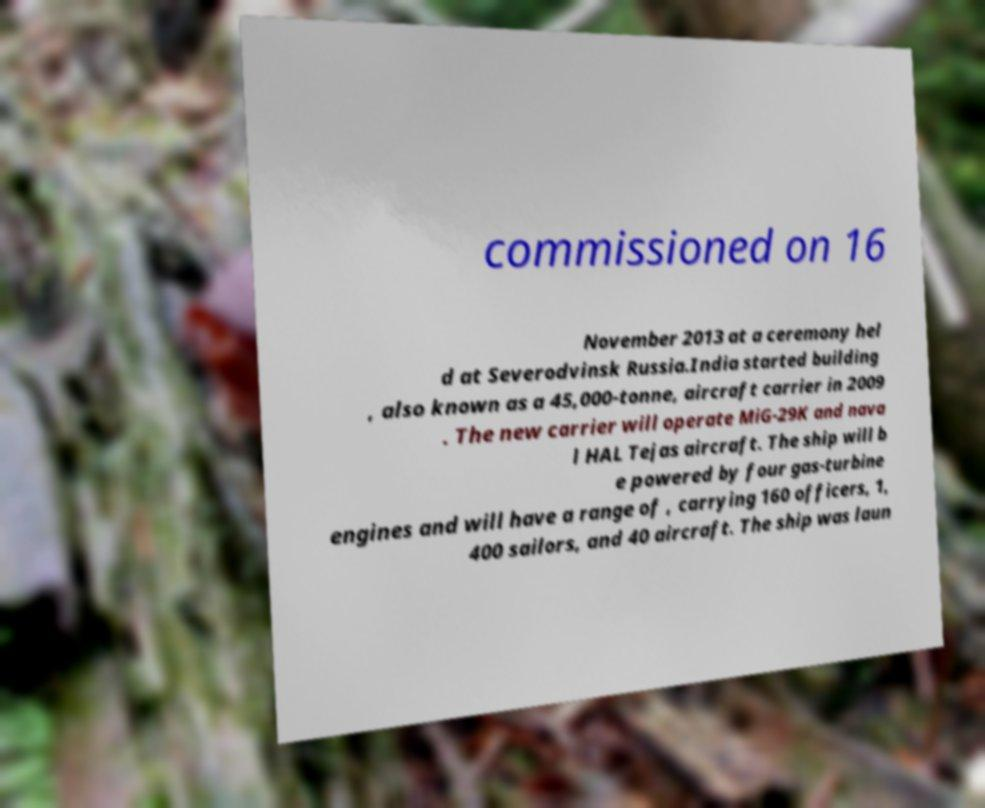What messages or text are displayed in this image? I need them in a readable, typed format. commissioned on 16 November 2013 at a ceremony hel d at Severodvinsk Russia.India started building , also known as a 45,000-tonne, aircraft carrier in 2009 . The new carrier will operate MiG-29K and nava l HAL Tejas aircraft. The ship will b e powered by four gas-turbine engines and will have a range of , carrying 160 officers, 1, 400 sailors, and 40 aircraft. The ship was laun 